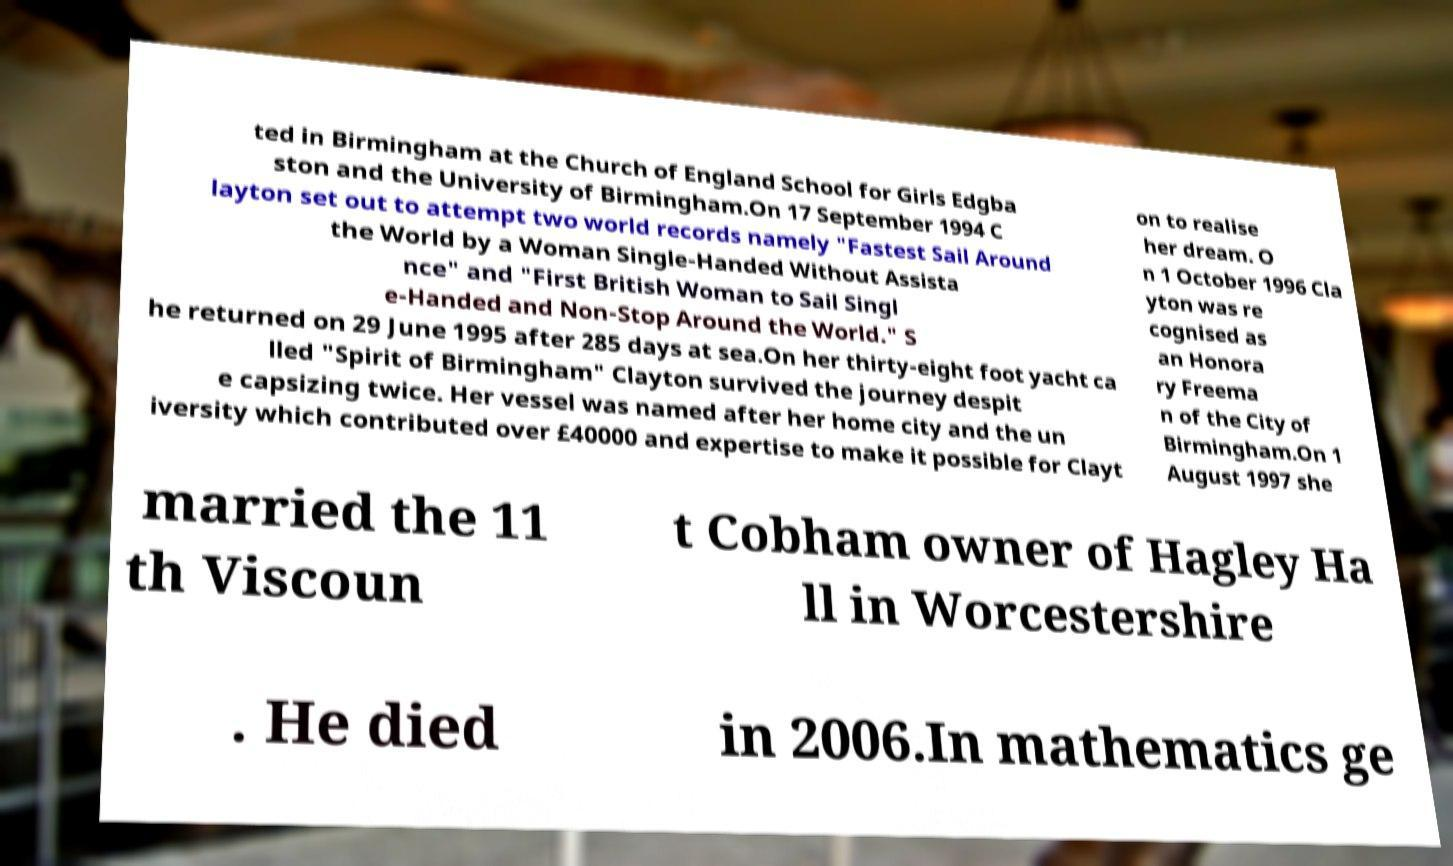Please read and relay the text visible in this image. What does it say? ted in Birmingham at the Church of England School for Girls Edgba ston and the University of Birmingham.On 17 September 1994 C layton set out to attempt two world records namely "Fastest Sail Around the World by a Woman Single-Handed Without Assista nce" and "First British Woman to Sail Singl e-Handed and Non-Stop Around the World." S he returned on 29 June 1995 after 285 days at sea.On her thirty-eight foot yacht ca lled "Spirit of Birmingham" Clayton survived the journey despit e capsizing twice. Her vessel was named after her home city and the un iversity which contributed over £40000 and expertise to make it possible for Clayt on to realise her dream. O n 1 October 1996 Cla yton was re cognised as an Honora ry Freema n of the City of Birmingham.On 1 August 1997 she married the 11 th Viscoun t Cobham owner of Hagley Ha ll in Worcestershire . He died in 2006.In mathematics ge 